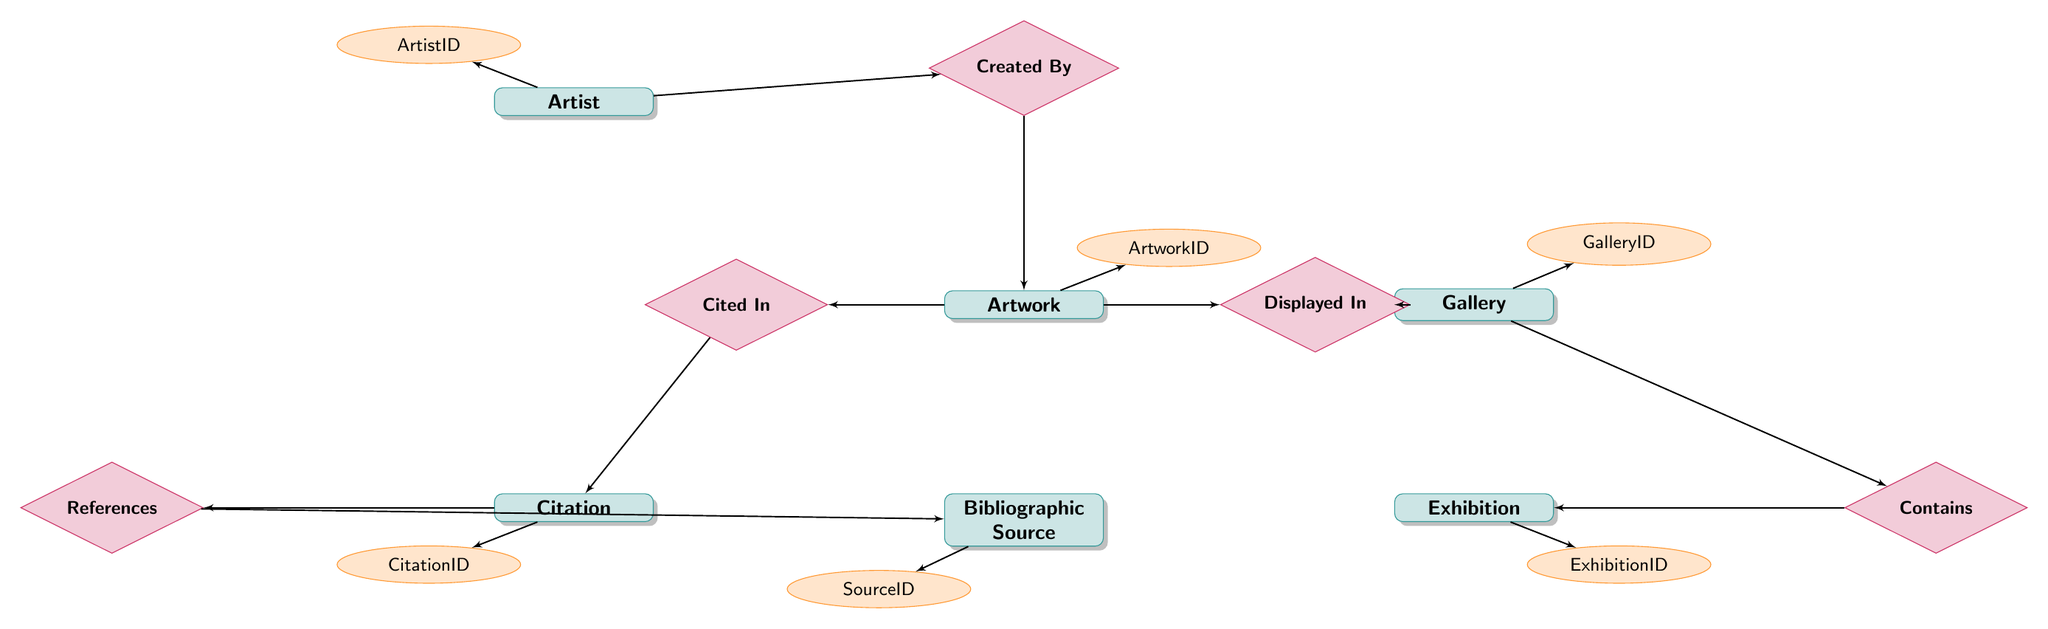What is the primary key for the Artwork entity? In the diagram, the primary key attribute for the Artwork entity is shown as ArtworkID, which is linked directly to the Artwork node.
Answer: ArtworkID How many entities are represented in the diagram? By counting the node shapes designated as entities in the diagram, there are six entities: Artwork, Bibliographic Source, Gallery, Exhibition, Artist, and Citation.
Answer: 6 What is the relationship type between Artist and Artwork? The diagram indicates that the relationship between Artist and Artwork is labeled as "Created By," which is a One-To-Many relationship.
Answer: One-To-Many Which entity has a Many-To-One relationship with Citation? The diagram shows that Citation has a Many-To-One relationship with Bibliographic Source, as depicted by the "References" relationship connecting them.
Answer: Bibliographic Source How does the Artwork entity relate to the Citation entity? The diagram depicts a One-To-Many relationship labeled as "Cited In," indicating that one Artwork can have multiple Citations associated with it.
Answer: Cited In What is the foreign key in the Citation entity? The foreign key in the Citation entity is indicated as SourceID, which establishes a relationship to the Bibliographic Source entity.
Answer: SourceID What entity is displayed in a Gallery according to the diagram? The diagram indicates that the Artwork entity is displayed in a Gallery through the relationship labeled as "Displayed In."
Answer: Artwork Which exhibition contains the Artwork? The relationship diagram indicates that the Exhibition entity, linked through the "Contains" relationship, is where the Artwork is displayed. The answer is Exhibition.
Answer: Exhibition What is the attribute that identifies each Bibliographic Source? The primary key attribute for each Bibliographic Source is indicated as SourceID, which uniquely identifies each record within that entity.
Answer: SourceID 